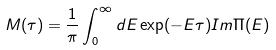Convert formula to latex. <formula><loc_0><loc_0><loc_500><loc_500>M ( \tau ) = \frac { 1 } { \pi } \int _ { 0 } ^ { \infty } d E \exp ( - E \tau ) { I m } \Pi ( E )</formula> 